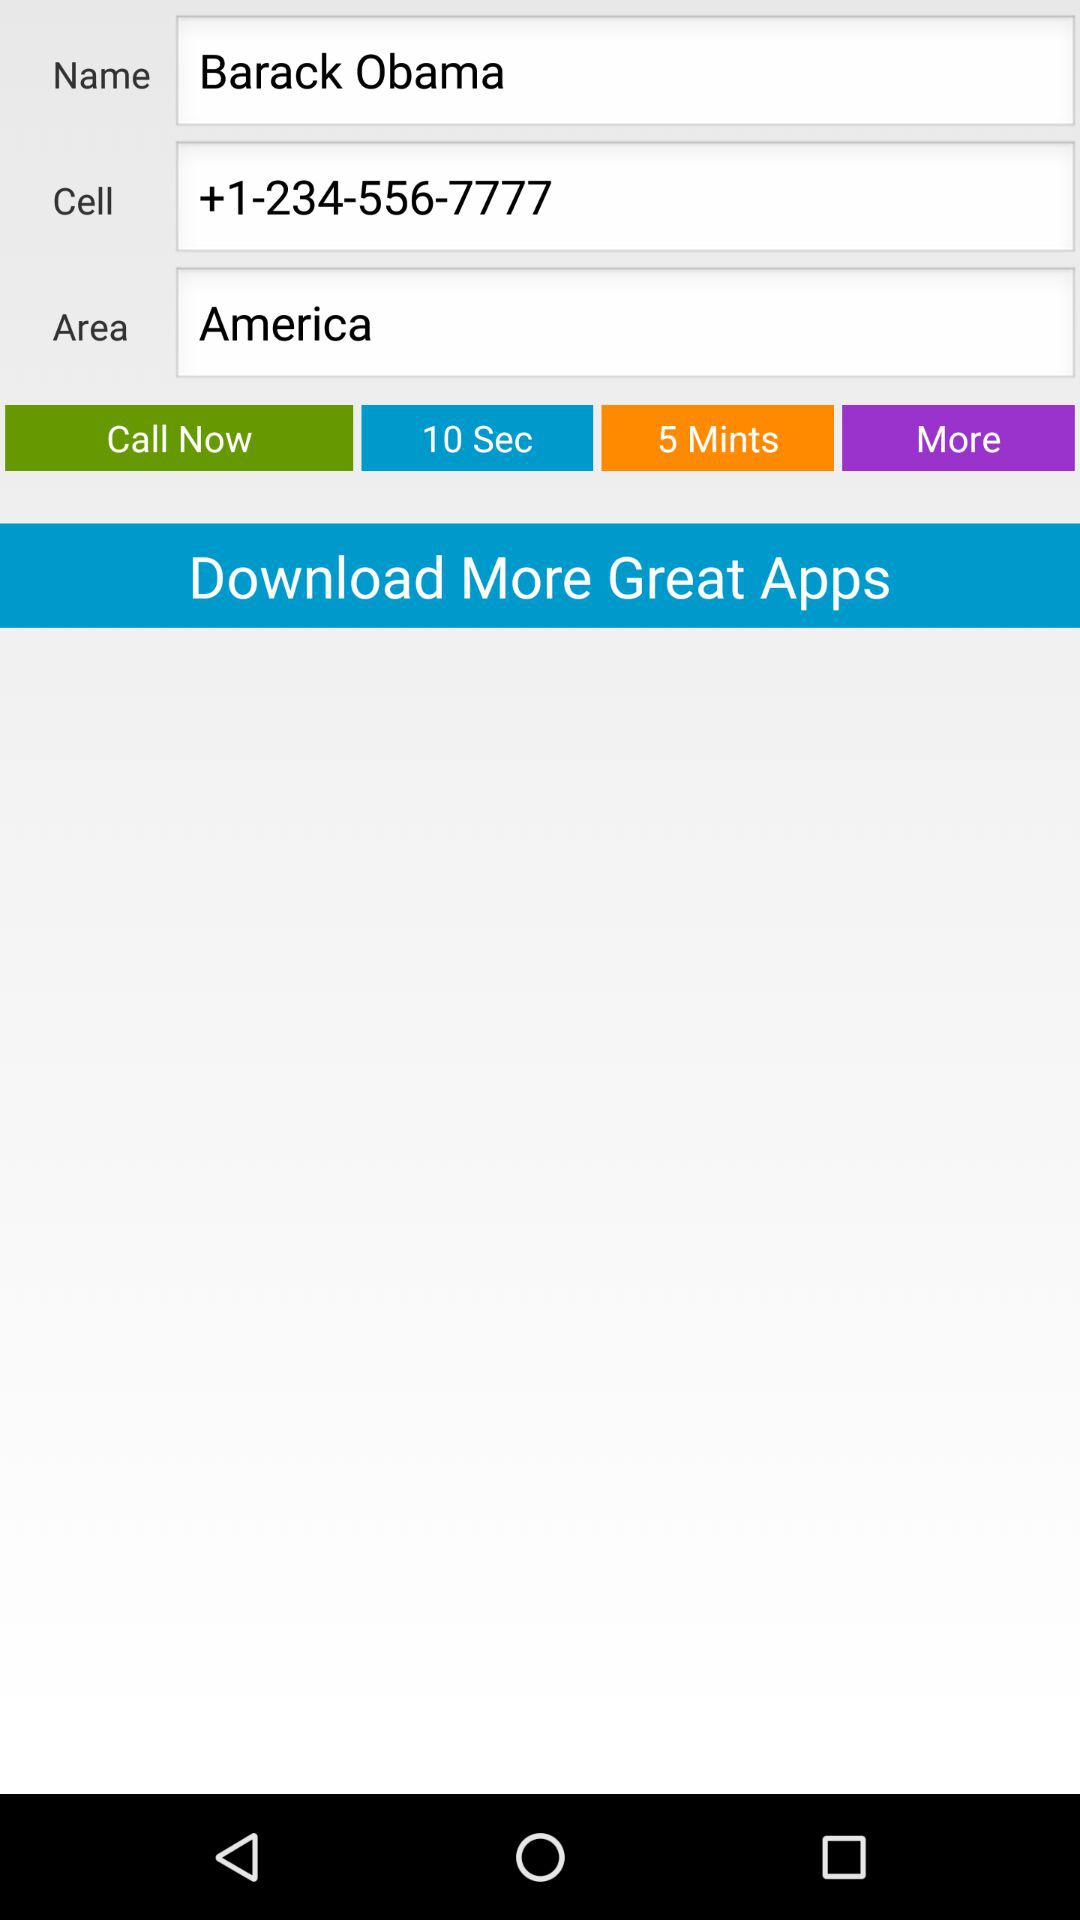What is the name? The name is Barack Obama. 